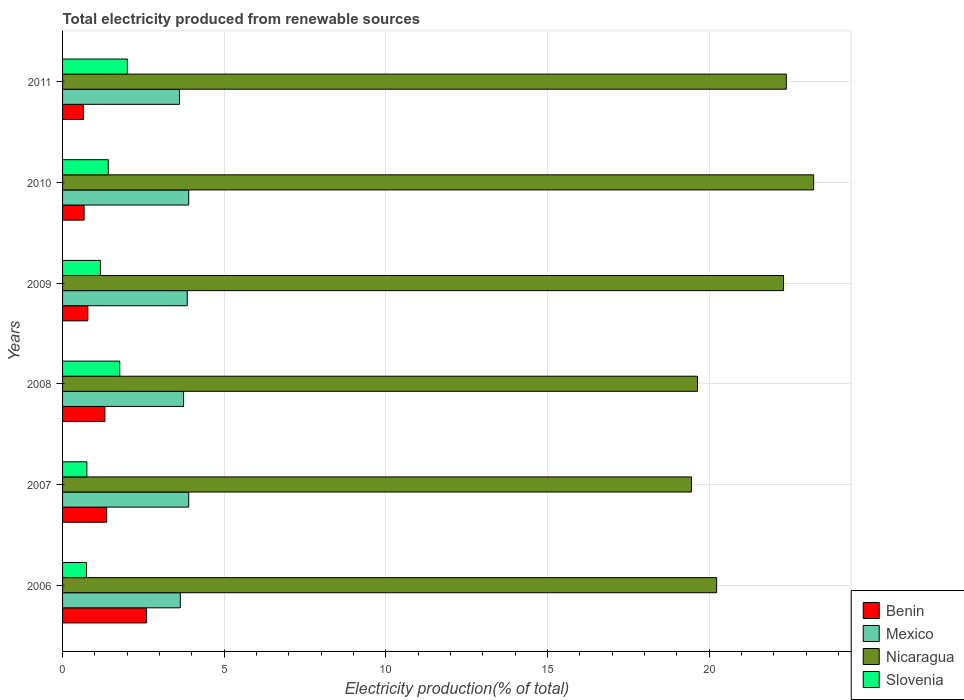Are the number of bars per tick equal to the number of legend labels?
Make the answer very short. Yes. Are the number of bars on each tick of the Y-axis equal?
Offer a terse response. Yes. How many bars are there on the 2nd tick from the top?
Provide a succinct answer. 4. How many bars are there on the 3rd tick from the bottom?
Offer a very short reply. 4. What is the label of the 4th group of bars from the top?
Provide a succinct answer. 2008. In how many cases, is the number of bars for a given year not equal to the number of legend labels?
Your answer should be compact. 0. What is the total electricity produced in Mexico in 2010?
Offer a very short reply. 3.9. Across all years, what is the maximum total electricity produced in Benin?
Your answer should be very brief. 2.6. Across all years, what is the minimum total electricity produced in Benin?
Offer a terse response. 0.65. In which year was the total electricity produced in Benin maximum?
Provide a short and direct response. 2006. What is the total total electricity produced in Mexico in the graph?
Your response must be concise. 22.66. What is the difference between the total electricity produced in Nicaragua in 2009 and that in 2010?
Offer a very short reply. -0.93. What is the difference between the total electricity produced in Nicaragua in 2009 and the total electricity produced in Mexico in 2007?
Give a very brief answer. 18.4. What is the average total electricity produced in Mexico per year?
Provide a short and direct response. 3.78. In the year 2008, what is the difference between the total electricity produced in Mexico and total electricity produced in Nicaragua?
Your answer should be compact. -15.89. What is the ratio of the total electricity produced in Nicaragua in 2006 to that in 2011?
Your answer should be very brief. 0.9. Is the total electricity produced in Slovenia in 2009 less than that in 2011?
Your response must be concise. Yes. What is the difference between the highest and the second highest total electricity produced in Slovenia?
Keep it short and to the point. 0.24. What is the difference between the highest and the lowest total electricity produced in Mexico?
Offer a terse response. 0.29. Is the sum of the total electricity produced in Slovenia in 2008 and 2010 greater than the maximum total electricity produced in Nicaragua across all years?
Your answer should be compact. No. Is it the case that in every year, the sum of the total electricity produced in Nicaragua and total electricity produced in Benin is greater than the sum of total electricity produced in Mexico and total electricity produced in Slovenia?
Provide a succinct answer. No. What does the 1st bar from the bottom in 2007 represents?
Your answer should be very brief. Benin. Is it the case that in every year, the sum of the total electricity produced in Slovenia and total electricity produced in Benin is greater than the total electricity produced in Mexico?
Your answer should be very brief. No. How many bars are there?
Make the answer very short. 24. What is the difference between two consecutive major ticks on the X-axis?
Make the answer very short. 5. Are the values on the major ticks of X-axis written in scientific E-notation?
Ensure brevity in your answer.  No. Does the graph contain any zero values?
Your answer should be compact. No. Does the graph contain grids?
Your answer should be very brief. Yes. How many legend labels are there?
Provide a short and direct response. 4. What is the title of the graph?
Your response must be concise. Total electricity produced from renewable sources. Does "Hungary" appear as one of the legend labels in the graph?
Ensure brevity in your answer.  No. What is the label or title of the Y-axis?
Provide a succinct answer. Years. What is the Electricity production(% of total) in Benin in 2006?
Provide a succinct answer. 2.6. What is the Electricity production(% of total) of Mexico in 2006?
Provide a succinct answer. 3.64. What is the Electricity production(% of total) in Nicaragua in 2006?
Provide a succinct answer. 20.23. What is the Electricity production(% of total) of Slovenia in 2006?
Your answer should be compact. 0.74. What is the Electricity production(% of total) in Benin in 2007?
Your response must be concise. 1.36. What is the Electricity production(% of total) in Mexico in 2007?
Provide a succinct answer. 3.9. What is the Electricity production(% of total) of Nicaragua in 2007?
Provide a succinct answer. 19.45. What is the Electricity production(% of total) in Slovenia in 2007?
Offer a very short reply. 0.75. What is the Electricity production(% of total) of Benin in 2008?
Give a very brief answer. 1.31. What is the Electricity production(% of total) in Mexico in 2008?
Your answer should be very brief. 3.74. What is the Electricity production(% of total) of Nicaragua in 2008?
Make the answer very short. 19.64. What is the Electricity production(% of total) in Slovenia in 2008?
Your answer should be compact. 1.77. What is the Electricity production(% of total) in Benin in 2009?
Offer a terse response. 0.78. What is the Electricity production(% of total) in Mexico in 2009?
Your answer should be compact. 3.86. What is the Electricity production(% of total) of Nicaragua in 2009?
Provide a succinct answer. 22.3. What is the Electricity production(% of total) in Slovenia in 2009?
Ensure brevity in your answer.  1.17. What is the Electricity production(% of total) of Benin in 2010?
Give a very brief answer. 0.67. What is the Electricity production(% of total) of Mexico in 2010?
Offer a very short reply. 3.9. What is the Electricity production(% of total) of Nicaragua in 2010?
Provide a short and direct response. 23.23. What is the Electricity production(% of total) in Slovenia in 2010?
Provide a short and direct response. 1.42. What is the Electricity production(% of total) of Benin in 2011?
Offer a terse response. 0.65. What is the Electricity production(% of total) of Mexico in 2011?
Give a very brief answer. 3.62. What is the Electricity production(% of total) of Nicaragua in 2011?
Make the answer very short. 22.38. What is the Electricity production(% of total) in Slovenia in 2011?
Your response must be concise. 2. Across all years, what is the maximum Electricity production(% of total) in Benin?
Your response must be concise. 2.6. Across all years, what is the maximum Electricity production(% of total) in Mexico?
Keep it short and to the point. 3.9. Across all years, what is the maximum Electricity production(% of total) in Nicaragua?
Provide a succinct answer. 23.23. Across all years, what is the maximum Electricity production(% of total) of Slovenia?
Your response must be concise. 2. Across all years, what is the minimum Electricity production(% of total) in Benin?
Give a very brief answer. 0.65. Across all years, what is the minimum Electricity production(% of total) of Mexico?
Your answer should be compact. 3.62. Across all years, what is the minimum Electricity production(% of total) of Nicaragua?
Make the answer very short. 19.45. Across all years, what is the minimum Electricity production(% of total) of Slovenia?
Offer a very short reply. 0.74. What is the total Electricity production(% of total) of Benin in the graph?
Offer a terse response. 7.36. What is the total Electricity production(% of total) in Mexico in the graph?
Provide a short and direct response. 22.66. What is the total Electricity production(% of total) in Nicaragua in the graph?
Provide a succinct answer. 127.23. What is the total Electricity production(% of total) of Slovenia in the graph?
Keep it short and to the point. 7.85. What is the difference between the Electricity production(% of total) in Benin in 2006 and that in 2007?
Give a very brief answer. 1.23. What is the difference between the Electricity production(% of total) in Mexico in 2006 and that in 2007?
Ensure brevity in your answer.  -0.26. What is the difference between the Electricity production(% of total) of Nicaragua in 2006 and that in 2007?
Provide a succinct answer. 0.78. What is the difference between the Electricity production(% of total) in Slovenia in 2006 and that in 2007?
Your response must be concise. -0.01. What is the difference between the Electricity production(% of total) in Benin in 2006 and that in 2008?
Offer a very short reply. 1.29. What is the difference between the Electricity production(% of total) in Mexico in 2006 and that in 2008?
Make the answer very short. -0.1. What is the difference between the Electricity production(% of total) of Nicaragua in 2006 and that in 2008?
Ensure brevity in your answer.  0.59. What is the difference between the Electricity production(% of total) in Slovenia in 2006 and that in 2008?
Make the answer very short. -1.03. What is the difference between the Electricity production(% of total) in Benin in 2006 and that in 2009?
Provide a short and direct response. 1.82. What is the difference between the Electricity production(% of total) in Mexico in 2006 and that in 2009?
Offer a terse response. -0.21. What is the difference between the Electricity production(% of total) in Nicaragua in 2006 and that in 2009?
Offer a terse response. -2.07. What is the difference between the Electricity production(% of total) of Slovenia in 2006 and that in 2009?
Give a very brief answer. -0.43. What is the difference between the Electricity production(% of total) in Benin in 2006 and that in 2010?
Offer a very short reply. 1.93. What is the difference between the Electricity production(% of total) in Mexico in 2006 and that in 2010?
Provide a succinct answer. -0.26. What is the difference between the Electricity production(% of total) in Nicaragua in 2006 and that in 2010?
Keep it short and to the point. -3. What is the difference between the Electricity production(% of total) of Slovenia in 2006 and that in 2010?
Give a very brief answer. -0.67. What is the difference between the Electricity production(% of total) in Benin in 2006 and that in 2011?
Provide a short and direct response. 1.95. What is the difference between the Electricity production(% of total) in Mexico in 2006 and that in 2011?
Give a very brief answer. 0.03. What is the difference between the Electricity production(% of total) in Nicaragua in 2006 and that in 2011?
Provide a short and direct response. -2.16. What is the difference between the Electricity production(% of total) of Slovenia in 2006 and that in 2011?
Offer a very short reply. -1.26. What is the difference between the Electricity production(% of total) in Benin in 2007 and that in 2008?
Provide a short and direct response. 0.05. What is the difference between the Electricity production(% of total) of Mexico in 2007 and that in 2008?
Keep it short and to the point. 0.16. What is the difference between the Electricity production(% of total) of Nicaragua in 2007 and that in 2008?
Your answer should be compact. -0.19. What is the difference between the Electricity production(% of total) of Slovenia in 2007 and that in 2008?
Ensure brevity in your answer.  -1.02. What is the difference between the Electricity production(% of total) in Benin in 2007 and that in 2009?
Your answer should be very brief. 0.58. What is the difference between the Electricity production(% of total) of Mexico in 2007 and that in 2009?
Keep it short and to the point. 0.05. What is the difference between the Electricity production(% of total) in Nicaragua in 2007 and that in 2009?
Your answer should be very brief. -2.85. What is the difference between the Electricity production(% of total) of Slovenia in 2007 and that in 2009?
Your answer should be compact. -0.42. What is the difference between the Electricity production(% of total) of Benin in 2007 and that in 2010?
Keep it short and to the point. 0.7. What is the difference between the Electricity production(% of total) of Mexico in 2007 and that in 2010?
Keep it short and to the point. -0. What is the difference between the Electricity production(% of total) of Nicaragua in 2007 and that in 2010?
Provide a short and direct response. -3.78. What is the difference between the Electricity production(% of total) in Slovenia in 2007 and that in 2010?
Ensure brevity in your answer.  -0.66. What is the difference between the Electricity production(% of total) in Benin in 2007 and that in 2011?
Your answer should be compact. 0.72. What is the difference between the Electricity production(% of total) of Mexico in 2007 and that in 2011?
Offer a very short reply. 0.29. What is the difference between the Electricity production(% of total) of Nicaragua in 2007 and that in 2011?
Offer a very short reply. -2.93. What is the difference between the Electricity production(% of total) of Slovenia in 2007 and that in 2011?
Offer a very short reply. -1.25. What is the difference between the Electricity production(% of total) of Benin in 2008 and that in 2009?
Offer a terse response. 0.53. What is the difference between the Electricity production(% of total) of Mexico in 2008 and that in 2009?
Your answer should be compact. -0.11. What is the difference between the Electricity production(% of total) of Nicaragua in 2008 and that in 2009?
Your answer should be compact. -2.66. What is the difference between the Electricity production(% of total) in Slovenia in 2008 and that in 2009?
Provide a succinct answer. 0.6. What is the difference between the Electricity production(% of total) of Benin in 2008 and that in 2010?
Provide a succinct answer. 0.64. What is the difference between the Electricity production(% of total) in Mexico in 2008 and that in 2010?
Your response must be concise. -0.16. What is the difference between the Electricity production(% of total) of Nicaragua in 2008 and that in 2010?
Make the answer very short. -3.59. What is the difference between the Electricity production(% of total) in Slovenia in 2008 and that in 2010?
Your answer should be compact. 0.35. What is the difference between the Electricity production(% of total) in Benin in 2008 and that in 2011?
Your response must be concise. 0.66. What is the difference between the Electricity production(% of total) of Mexico in 2008 and that in 2011?
Offer a terse response. 0.13. What is the difference between the Electricity production(% of total) of Nicaragua in 2008 and that in 2011?
Offer a terse response. -2.75. What is the difference between the Electricity production(% of total) of Slovenia in 2008 and that in 2011?
Ensure brevity in your answer.  -0.24. What is the difference between the Electricity production(% of total) in Benin in 2009 and that in 2010?
Provide a short and direct response. 0.11. What is the difference between the Electricity production(% of total) of Mexico in 2009 and that in 2010?
Your answer should be compact. -0.05. What is the difference between the Electricity production(% of total) in Nicaragua in 2009 and that in 2010?
Your answer should be very brief. -0.93. What is the difference between the Electricity production(% of total) of Slovenia in 2009 and that in 2010?
Your response must be concise. -0.24. What is the difference between the Electricity production(% of total) in Benin in 2009 and that in 2011?
Your answer should be compact. 0.14. What is the difference between the Electricity production(% of total) of Mexico in 2009 and that in 2011?
Offer a terse response. 0.24. What is the difference between the Electricity production(% of total) of Nicaragua in 2009 and that in 2011?
Provide a short and direct response. -0.09. What is the difference between the Electricity production(% of total) in Slovenia in 2009 and that in 2011?
Ensure brevity in your answer.  -0.83. What is the difference between the Electricity production(% of total) in Benin in 2010 and that in 2011?
Ensure brevity in your answer.  0.02. What is the difference between the Electricity production(% of total) of Mexico in 2010 and that in 2011?
Offer a terse response. 0.29. What is the difference between the Electricity production(% of total) of Nicaragua in 2010 and that in 2011?
Keep it short and to the point. 0.85. What is the difference between the Electricity production(% of total) in Slovenia in 2010 and that in 2011?
Provide a succinct answer. -0.59. What is the difference between the Electricity production(% of total) of Benin in 2006 and the Electricity production(% of total) of Mexico in 2007?
Keep it short and to the point. -1.3. What is the difference between the Electricity production(% of total) in Benin in 2006 and the Electricity production(% of total) in Nicaragua in 2007?
Offer a very short reply. -16.85. What is the difference between the Electricity production(% of total) in Benin in 2006 and the Electricity production(% of total) in Slovenia in 2007?
Provide a succinct answer. 1.85. What is the difference between the Electricity production(% of total) of Mexico in 2006 and the Electricity production(% of total) of Nicaragua in 2007?
Provide a succinct answer. -15.81. What is the difference between the Electricity production(% of total) of Mexico in 2006 and the Electricity production(% of total) of Slovenia in 2007?
Your answer should be compact. 2.89. What is the difference between the Electricity production(% of total) of Nicaragua in 2006 and the Electricity production(% of total) of Slovenia in 2007?
Your response must be concise. 19.48. What is the difference between the Electricity production(% of total) of Benin in 2006 and the Electricity production(% of total) of Mexico in 2008?
Your response must be concise. -1.15. What is the difference between the Electricity production(% of total) of Benin in 2006 and the Electricity production(% of total) of Nicaragua in 2008?
Provide a short and direct response. -17.04. What is the difference between the Electricity production(% of total) in Benin in 2006 and the Electricity production(% of total) in Slovenia in 2008?
Your answer should be very brief. 0.83. What is the difference between the Electricity production(% of total) in Mexico in 2006 and the Electricity production(% of total) in Nicaragua in 2008?
Provide a short and direct response. -16. What is the difference between the Electricity production(% of total) in Mexico in 2006 and the Electricity production(% of total) in Slovenia in 2008?
Ensure brevity in your answer.  1.87. What is the difference between the Electricity production(% of total) in Nicaragua in 2006 and the Electricity production(% of total) in Slovenia in 2008?
Your answer should be compact. 18.46. What is the difference between the Electricity production(% of total) of Benin in 2006 and the Electricity production(% of total) of Mexico in 2009?
Offer a very short reply. -1.26. What is the difference between the Electricity production(% of total) in Benin in 2006 and the Electricity production(% of total) in Nicaragua in 2009?
Make the answer very short. -19.7. What is the difference between the Electricity production(% of total) of Benin in 2006 and the Electricity production(% of total) of Slovenia in 2009?
Give a very brief answer. 1.43. What is the difference between the Electricity production(% of total) of Mexico in 2006 and the Electricity production(% of total) of Nicaragua in 2009?
Provide a short and direct response. -18.66. What is the difference between the Electricity production(% of total) in Mexico in 2006 and the Electricity production(% of total) in Slovenia in 2009?
Your answer should be very brief. 2.47. What is the difference between the Electricity production(% of total) in Nicaragua in 2006 and the Electricity production(% of total) in Slovenia in 2009?
Make the answer very short. 19.06. What is the difference between the Electricity production(% of total) of Benin in 2006 and the Electricity production(% of total) of Mexico in 2010?
Offer a terse response. -1.3. What is the difference between the Electricity production(% of total) of Benin in 2006 and the Electricity production(% of total) of Nicaragua in 2010?
Offer a very short reply. -20.63. What is the difference between the Electricity production(% of total) in Benin in 2006 and the Electricity production(% of total) in Slovenia in 2010?
Offer a terse response. 1.18. What is the difference between the Electricity production(% of total) in Mexico in 2006 and the Electricity production(% of total) in Nicaragua in 2010?
Your response must be concise. -19.59. What is the difference between the Electricity production(% of total) in Mexico in 2006 and the Electricity production(% of total) in Slovenia in 2010?
Give a very brief answer. 2.23. What is the difference between the Electricity production(% of total) of Nicaragua in 2006 and the Electricity production(% of total) of Slovenia in 2010?
Make the answer very short. 18.81. What is the difference between the Electricity production(% of total) in Benin in 2006 and the Electricity production(% of total) in Mexico in 2011?
Your answer should be very brief. -1.02. What is the difference between the Electricity production(% of total) in Benin in 2006 and the Electricity production(% of total) in Nicaragua in 2011?
Make the answer very short. -19.79. What is the difference between the Electricity production(% of total) of Benin in 2006 and the Electricity production(% of total) of Slovenia in 2011?
Your response must be concise. 0.59. What is the difference between the Electricity production(% of total) in Mexico in 2006 and the Electricity production(% of total) in Nicaragua in 2011?
Keep it short and to the point. -18.74. What is the difference between the Electricity production(% of total) in Mexico in 2006 and the Electricity production(% of total) in Slovenia in 2011?
Keep it short and to the point. 1.64. What is the difference between the Electricity production(% of total) in Nicaragua in 2006 and the Electricity production(% of total) in Slovenia in 2011?
Your answer should be compact. 18.23. What is the difference between the Electricity production(% of total) of Benin in 2007 and the Electricity production(% of total) of Mexico in 2008?
Your response must be concise. -2.38. What is the difference between the Electricity production(% of total) of Benin in 2007 and the Electricity production(% of total) of Nicaragua in 2008?
Offer a very short reply. -18.27. What is the difference between the Electricity production(% of total) in Benin in 2007 and the Electricity production(% of total) in Slovenia in 2008?
Your answer should be very brief. -0.4. What is the difference between the Electricity production(% of total) of Mexico in 2007 and the Electricity production(% of total) of Nicaragua in 2008?
Give a very brief answer. -15.74. What is the difference between the Electricity production(% of total) of Mexico in 2007 and the Electricity production(% of total) of Slovenia in 2008?
Ensure brevity in your answer.  2.13. What is the difference between the Electricity production(% of total) in Nicaragua in 2007 and the Electricity production(% of total) in Slovenia in 2008?
Give a very brief answer. 17.68. What is the difference between the Electricity production(% of total) of Benin in 2007 and the Electricity production(% of total) of Mexico in 2009?
Keep it short and to the point. -2.49. What is the difference between the Electricity production(% of total) in Benin in 2007 and the Electricity production(% of total) in Nicaragua in 2009?
Your response must be concise. -20.94. What is the difference between the Electricity production(% of total) of Benin in 2007 and the Electricity production(% of total) of Slovenia in 2009?
Your answer should be very brief. 0.19. What is the difference between the Electricity production(% of total) in Mexico in 2007 and the Electricity production(% of total) in Nicaragua in 2009?
Ensure brevity in your answer.  -18.4. What is the difference between the Electricity production(% of total) of Mexico in 2007 and the Electricity production(% of total) of Slovenia in 2009?
Provide a succinct answer. 2.73. What is the difference between the Electricity production(% of total) in Nicaragua in 2007 and the Electricity production(% of total) in Slovenia in 2009?
Ensure brevity in your answer.  18.28. What is the difference between the Electricity production(% of total) of Benin in 2007 and the Electricity production(% of total) of Mexico in 2010?
Provide a succinct answer. -2.54. What is the difference between the Electricity production(% of total) in Benin in 2007 and the Electricity production(% of total) in Nicaragua in 2010?
Your answer should be very brief. -21.87. What is the difference between the Electricity production(% of total) in Benin in 2007 and the Electricity production(% of total) in Slovenia in 2010?
Offer a terse response. -0.05. What is the difference between the Electricity production(% of total) of Mexico in 2007 and the Electricity production(% of total) of Nicaragua in 2010?
Your answer should be very brief. -19.33. What is the difference between the Electricity production(% of total) of Mexico in 2007 and the Electricity production(% of total) of Slovenia in 2010?
Ensure brevity in your answer.  2.49. What is the difference between the Electricity production(% of total) of Nicaragua in 2007 and the Electricity production(% of total) of Slovenia in 2010?
Your answer should be very brief. 18.04. What is the difference between the Electricity production(% of total) in Benin in 2007 and the Electricity production(% of total) in Mexico in 2011?
Offer a terse response. -2.25. What is the difference between the Electricity production(% of total) in Benin in 2007 and the Electricity production(% of total) in Nicaragua in 2011?
Offer a terse response. -21.02. What is the difference between the Electricity production(% of total) of Benin in 2007 and the Electricity production(% of total) of Slovenia in 2011?
Your response must be concise. -0.64. What is the difference between the Electricity production(% of total) in Mexico in 2007 and the Electricity production(% of total) in Nicaragua in 2011?
Keep it short and to the point. -18.48. What is the difference between the Electricity production(% of total) of Mexico in 2007 and the Electricity production(% of total) of Slovenia in 2011?
Make the answer very short. 1.9. What is the difference between the Electricity production(% of total) of Nicaragua in 2007 and the Electricity production(% of total) of Slovenia in 2011?
Your response must be concise. 17.45. What is the difference between the Electricity production(% of total) in Benin in 2008 and the Electricity production(% of total) in Mexico in 2009?
Your response must be concise. -2.55. What is the difference between the Electricity production(% of total) of Benin in 2008 and the Electricity production(% of total) of Nicaragua in 2009?
Offer a very short reply. -20.99. What is the difference between the Electricity production(% of total) in Benin in 2008 and the Electricity production(% of total) in Slovenia in 2009?
Provide a short and direct response. 0.14. What is the difference between the Electricity production(% of total) of Mexico in 2008 and the Electricity production(% of total) of Nicaragua in 2009?
Give a very brief answer. -18.56. What is the difference between the Electricity production(% of total) in Mexico in 2008 and the Electricity production(% of total) in Slovenia in 2009?
Offer a very short reply. 2.57. What is the difference between the Electricity production(% of total) of Nicaragua in 2008 and the Electricity production(% of total) of Slovenia in 2009?
Make the answer very short. 18.47. What is the difference between the Electricity production(% of total) in Benin in 2008 and the Electricity production(% of total) in Mexico in 2010?
Your answer should be compact. -2.59. What is the difference between the Electricity production(% of total) of Benin in 2008 and the Electricity production(% of total) of Nicaragua in 2010?
Keep it short and to the point. -21.92. What is the difference between the Electricity production(% of total) in Benin in 2008 and the Electricity production(% of total) in Slovenia in 2010?
Your answer should be compact. -0.11. What is the difference between the Electricity production(% of total) of Mexico in 2008 and the Electricity production(% of total) of Nicaragua in 2010?
Make the answer very short. -19.49. What is the difference between the Electricity production(% of total) in Mexico in 2008 and the Electricity production(% of total) in Slovenia in 2010?
Offer a very short reply. 2.33. What is the difference between the Electricity production(% of total) of Nicaragua in 2008 and the Electricity production(% of total) of Slovenia in 2010?
Ensure brevity in your answer.  18.22. What is the difference between the Electricity production(% of total) in Benin in 2008 and the Electricity production(% of total) in Mexico in 2011?
Provide a short and direct response. -2.31. What is the difference between the Electricity production(% of total) of Benin in 2008 and the Electricity production(% of total) of Nicaragua in 2011?
Give a very brief answer. -21.07. What is the difference between the Electricity production(% of total) in Benin in 2008 and the Electricity production(% of total) in Slovenia in 2011?
Offer a very short reply. -0.69. What is the difference between the Electricity production(% of total) of Mexico in 2008 and the Electricity production(% of total) of Nicaragua in 2011?
Provide a short and direct response. -18.64. What is the difference between the Electricity production(% of total) of Mexico in 2008 and the Electricity production(% of total) of Slovenia in 2011?
Offer a very short reply. 1.74. What is the difference between the Electricity production(% of total) in Nicaragua in 2008 and the Electricity production(% of total) in Slovenia in 2011?
Provide a short and direct response. 17.63. What is the difference between the Electricity production(% of total) in Benin in 2009 and the Electricity production(% of total) in Mexico in 2010?
Keep it short and to the point. -3.12. What is the difference between the Electricity production(% of total) of Benin in 2009 and the Electricity production(% of total) of Nicaragua in 2010?
Offer a terse response. -22.45. What is the difference between the Electricity production(% of total) of Benin in 2009 and the Electricity production(% of total) of Slovenia in 2010?
Provide a short and direct response. -0.63. What is the difference between the Electricity production(% of total) of Mexico in 2009 and the Electricity production(% of total) of Nicaragua in 2010?
Offer a terse response. -19.37. What is the difference between the Electricity production(% of total) of Mexico in 2009 and the Electricity production(% of total) of Slovenia in 2010?
Your response must be concise. 2.44. What is the difference between the Electricity production(% of total) in Nicaragua in 2009 and the Electricity production(% of total) in Slovenia in 2010?
Your response must be concise. 20.88. What is the difference between the Electricity production(% of total) of Benin in 2009 and the Electricity production(% of total) of Mexico in 2011?
Keep it short and to the point. -2.83. What is the difference between the Electricity production(% of total) in Benin in 2009 and the Electricity production(% of total) in Nicaragua in 2011?
Your response must be concise. -21.6. What is the difference between the Electricity production(% of total) of Benin in 2009 and the Electricity production(% of total) of Slovenia in 2011?
Your response must be concise. -1.22. What is the difference between the Electricity production(% of total) in Mexico in 2009 and the Electricity production(% of total) in Nicaragua in 2011?
Make the answer very short. -18.53. What is the difference between the Electricity production(% of total) of Mexico in 2009 and the Electricity production(% of total) of Slovenia in 2011?
Give a very brief answer. 1.85. What is the difference between the Electricity production(% of total) of Nicaragua in 2009 and the Electricity production(% of total) of Slovenia in 2011?
Your answer should be compact. 20.29. What is the difference between the Electricity production(% of total) of Benin in 2010 and the Electricity production(% of total) of Mexico in 2011?
Give a very brief answer. -2.95. What is the difference between the Electricity production(% of total) of Benin in 2010 and the Electricity production(% of total) of Nicaragua in 2011?
Keep it short and to the point. -21.72. What is the difference between the Electricity production(% of total) in Benin in 2010 and the Electricity production(% of total) in Slovenia in 2011?
Ensure brevity in your answer.  -1.34. What is the difference between the Electricity production(% of total) in Mexico in 2010 and the Electricity production(% of total) in Nicaragua in 2011?
Provide a succinct answer. -18.48. What is the difference between the Electricity production(% of total) of Mexico in 2010 and the Electricity production(% of total) of Slovenia in 2011?
Your response must be concise. 1.9. What is the difference between the Electricity production(% of total) of Nicaragua in 2010 and the Electricity production(% of total) of Slovenia in 2011?
Make the answer very short. 21.23. What is the average Electricity production(% of total) of Benin per year?
Your answer should be very brief. 1.23. What is the average Electricity production(% of total) of Mexico per year?
Offer a terse response. 3.78. What is the average Electricity production(% of total) of Nicaragua per year?
Give a very brief answer. 21.21. What is the average Electricity production(% of total) in Slovenia per year?
Your answer should be compact. 1.31. In the year 2006, what is the difference between the Electricity production(% of total) of Benin and Electricity production(% of total) of Mexico?
Make the answer very short. -1.04. In the year 2006, what is the difference between the Electricity production(% of total) of Benin and Electricity production(% of total) of Nicaragua?
Provide a short and direct response. -17.63. In the year 2006, what is the difference between the Electricity production(% of total) in Benin and Electricity production(% of total) in Slovenia?
Your response must be concise. 1.86. In the year 2006, what is the difference between the Electricity production(% of total) in Mexico and Electricity production(% of total) in Nicaragua?
Ensure brevity in your answer.  -16.59. In the year 2006, what is the difference between the Electricity production(% of total) in Mexico and Electricity production(% of total) in Slovenia?
Offer a very short reply. 2.9. In the year 2006, what is the difference between the Electricity production(% of total) in Nicaragua and Electricity production(% of total) in Slovenia?
Provide a short and direct response. 19.49. In the year 2007, what is the difference between the Electricity production(% of total) of Benin and Electricity production(% of total) of Mexico?
Give a very brief answer. -2.54. In the year 2007, what is the difference between the Electricity production(% of total) of Benin and Electricity production(% of total) of Nicaragua?
Ensure brevity in your answer.  -18.09. In the year 2007, what is the difference between the Electricity production(% of total) in Benin and Electricity production(% of total) in Slovenia?
Your answer should be very brief. 0.61. In the year 2007, what is the difference between the Electricity production(% of total) of Mexico and Electricity production(% of total) of Nicaragua?
Offer a terse response. -15.55. In the year 2007, what is the difference between the Electricity production(% of total) in Mexico and Electricity production(% of total) in Slovenia?
Keep it short and to the point. 3.15. In the year 2007, what is the difference between the Electricity production(% of total) in Nicaragua and Electricity production(% of total) in Slovenia?
Give a very brief answer. 18.7. In the year 2008, what is the difference between the Electricity production(% of total) of Benin and Electricity production(% of total) of Mexico?
Make the answer very short. -2.43. In the year 2008, what is the difference between the Electricity production(% of total) of Benin and Electricity production(% of total) of Nicaragua?
Offer a terse response. -18.33. In the year 2008, what is the difference between the Electricity production(% of total) in Benin and Electricity production(% of total) in Slovenia?
Ensure brevity in your answer.  -0.46. In the year 2008, what is the difference between the Electricity production(% of total) of Mexico and Electricity production(% of total) of Nicaragua?
Your answer should be very brief. -15.89. In the year 2008, what is the difference between the Electricity production(% of total) of Mexico and Electricity production(% of total) of Slovenia?
Ensure brevity in your answer.  1.97. In the year 2008, what is the difference between the Electricity production(% of total) of Nicaragua and Electricity production(% of total) of Slovenia?
Provide a short and direct response. 17.87. In the year 2009, what is the difference between the Electricity production(% of total) in Benin and Electricity production(% of total) in Mexico?
Offer a terse response. -3.07. In the year 2009, what is the difference between the Electricity production(% of total) in Benin and Electricity production(% of total) in Nicaragua?
Make the answer very short. -21.52. In the year 2009, what is the difference between the Electricity production(% of total) of Benin and Electricity production(% of total) of Slovenia?
Give a very brief answer. -0.39. In the year 2009, what is the difference between the Electricity production(% of total) of Mexico and Electricity production(% of total) of Nicaragua?
Provide a succinct answer. -18.44. In the year 2009, what is the difference between the Electricity production(% of total) of Mexico and Electricity production(% of total) of Slovenia?
Your answer should be very brief. 2.69. In the year 2009, what is the difference between the Electricity production(% of total) of Nicaragua and Electricity production(% of total) of Slovenia?
Give a very brief answer. 21.13. In the year 2010, what is the difference between the Electricity production(% of total) of Benin and Electricity production(% of total) of Mexico?
Offer a terse response. -3.24. In the year 2010, what is the difference between the Electricity production(% of total) in Benin and Electricity production(% of total) in Nicaragua?
Your answer should be compact. -22.56. In the year 2010, what is the difference between the Electricity production(% of total) of Benin and Electricity production(% of total) of Slovenia?
Provide a succinct answer. -0.75. In the year 2010, what is the difference between the Electricity production(% of total) of Mexico and Electricity production(% of total) of Nicaragua?
Ensure brevity in your answer.  -19.33. In the year 2010, what is the difference between the Electricity production(% of total) in Mexico and Electricity production(% of total) in Slovenia?
Your answer should be compact. 2.49. In the year 2010, what is the difference between the Electricity production(% of total) of Nicaragua and Electricity production(% of total) of Slovenia?
Offer a very short reply. 21.81. In the year 2011, what is the difference between the Electricity production(% of total) in Benin and Electricity production(% of total) in Mexico?
Offer a very short reply. -2.97. In the year 2011, what is the difference between the Electricity production(% of total) of Benin and Electricity production(% of total) of Nicaragua?
Give a very brief answer. -21.74. In the year 2011, what is the difference between the Electricity production(% of total) in Benin and Electricity production(% of total) in Slovenia?
Your response must be concise. -1.36. In the year 2011, what is the difference between the Electricity production(% of total) of Mexico and Electricity production(% of total) of Nicaragua?
Offer a terse response. -18.77. In the year 2011, what is the difference between the Electricity production(% of total) of Mexico and Electricity production(% of total) of Slovenia?
Keep it short and to the point. 1.61. In the year 2011, what is the difference between the Electricity production(% of total) of Nicaragua and Electricity production(% of total) of Slovenia?
Provide a succinct answer. 20.38. What is the ratio of the Electricity production(% of total) in Benin in 2006 to that in 2007?
Offer a very short reply. 1.9. What is the ratio of the Electricity production(% of total) of Mexico in 2006 to that in 2007?
Your response must be concise. 0.93. What is the ratio of the Electricity production(% of total) in Slovenia in 2006 to that in 2007?
Give a very brief answer. 0.99. What is the ratio of the Electricity production(% of total) of Benin in 2006 to that in 2008?
Provide a succinct answer. 1.98. What is the ratio of the Electricity production(% of total) in Mexico in 2006 to that in 2008?
Your answer should be very brief. 0.97. What is the ratio of the Electricity production(% of total) in Nicaragua in 2006 to that in 2008?
Make the answer very short. 1.03. What is the ratio of the Electricity production(% of total) of Slovenia in 2006 to that in 2008?
Offer a terse response. 0.42. What is the ratio of the Electricity production(% of total) in Benin in 2006 to that in 2009?
Ensure brevity in your answer.  3.32. What is the ratio of the Electricity production(% of total) in Mexico in 2006 to that in 2009?
Give a very brief answer. 0.94. What is the ratio of the Electricity production(% of total) of Nicaragua in 2006 to that in 2009?
Make the answer very short. 0.91. What is the ratio of the Electricity production(% of total) in Slovenia in 2006 to that in 2009?
Give a very brief answer. 0.63. What is the ratio of the Electricity production(% of total) in Benin in 2006 to that in 2010?
Give a very brief answer. 3.9. What is the ratio of the Electricity production(% of total) of Mexico in 2006 to that in 2010?
Keep it short and to the point. 0.93. What is the ratio of the Electricity production(% of total) of Nicaragua in 2006 to that in 2010?
Your answer should be very brief. 0.87. What is the ratio of the Electricity production(% of total) of Slovenia in 2006 to that in 2010?
Keep it short and to the point. 0.52. What is the ratio of the Electricity production(% of total) of Benin in 2006 to that in 2011?
Make the answer very short. 4.03. What is the ratio of the Electricity production(% of total) in Mexico in 2006 to that in 2011?
Offer a very short reply. 1.01. What is the ratio of the Electricity production(% of total) in Nicaragua in 2006 to that in 2011?
Provide a succinct answer. 0.9. What is the ratio of the Electricity production(% of total) of Slovenia in 2006 to that in 2011?
Make the answer very short. 0.37. What is the ratio of the Electricity production(% of total) in Benin in 2007 to that in 2008?
Your answer should be compact. 1.04. What is the ratio of the Electricity production(% of total) of Mexico in 2007 to that in 2008?
Offer a very short reply. 1.04. What is the ratio of the Electricity production(% of total) of Slovenia in 2007 to that in 2008?
Provide a succinct answer. 0.42. What is the ratio of the Electricity production(% of total) in Benin in 2007 to that in 2009?
Your answer should be very brief. 1.75. What is the ratio of the Electricity production(% of total) of Mexico in 2007 to that in 2009?
Your response must be concise. 1.01. What is the ratio of the Electricity production(% of total) of Nicaragua in 2007 to that in 2009?
Your answer should be very brief. 0.87. What is the ratio of the Electricity production(% of total) of Slovenia in 2007 to that in 2009?
Give a very brief answer. 0.64. What is the ratio of the Electricity production(% of total) of Benin in 2007 to that in 2010?
Offer a terse response. 2.05. What is the ratio of the Electricity production(% of total) in Mexico in 2007 to that in 2010?
Make the answer very short. 1. What is the ratio of the Electricity production(% of total) of Nicaragua in 2007 to that in 2010?
Offer a terse response. 0.84. What is the ratio of the Electricity production(% of total) of Slovenia in 2007 to that in 2010?
Keep it short and to the point. 0.53. What is the ratio of the Electricity production(% of total) in Benin in 2007 to that in 2011?
Make the answer very short. 2.11. What is the ratio of the Electricity production(% of total) of Mexico in 2007 to that in 2011?
Provide a short and direct response. 1.08. What is the ratio of the Electricity production(% of total) of Nicaragua in 2007 to that in 2011?
Give a very brief answer. 0.87. What is the ratio of the Electricity production(% of total) of Slovenia in 2007 to that in 2011?
Your answer should be very brief. 0.37. What is the ratio of the Electricity production(% of total) in Benin in 2008 to that in 2009?
Your response must be concise. 1.68. What is the ratio of the Electricity production(% of total) of Mexico in 2008 to that in 2009?
Your response must be concise. 0.97. What is the ratio of the Electricity production(% of total) in Nicaragua in 2008 to that in 2009?
Your response must be concise. 0.88. What is the ratio of the Electricity production(% of total) of Slovenia in 2008 to that in 2009?
Provide a short and direct response. 1.51. What is the ratio of the Electricity production(% of total) in Benin in 2008 to that in 2010?
Your answer should be very brief. 1.97. What is the ratio of the Electricity production(% of total) of Mexico in 2008 to that in 2010?
Keep it short and to the point. 0.96. What is the ratio of the Electricity production(% of total) in Nicaragua in 2008 to that in 2010?
Keep it short and to the point. 0.85. What is the ratio of the Electricity production(% of total) of Slovenia in 2008 to that in 2010?
Offer a terse response. 1.25. What is the ratio of the Electricity production(% of total) in Benin in 2008 to that in 2011?
Your answer should be compact. 2.03. What is the ratio of the Electricity production(% of total) of Mexico in 2008 to that in 2011?
Keep it short and to the point. 1.04. What is the ratio of the Electricity production(% of total) of Nicaragua in 2008 to that in 2011?
Provide a short and direct response. 0.88. What is the ratio of the Electricity production(% of total) in Slovenia in 2008 to that in 2011?
Your response must be concise. 0.88. What is the ratio of the Electricity production(% of total) of Benin in 2009 to that in 2010?
Offer a terse response. 1.17. What is the ratio of the Electricity production(% of total) of Mexico in 2009 to that in 2010?
Offer a terse response. 0.99. What is the ratio of the Electricity production(% of total) of Nicaragua in 2009 to that in 2010?
Keep it short and to the point. 0.96. What is the ratio of the Electricity production(% of total) of Slovenia in 2009 to that in 2010?
Provide a short and direct response. 0.83. What is the ratio of the Electricity production(% of total) in Benin in 2009 to that in 2011?
Ensure brevity in your answer.  1.21. What is the ratio of the Electricity production(% of total) of Mexico in 2009 to that in 2011?
Your answer should be very brief. 1.07. What is the ratio of the Electricity production(% of total) in Slovenia in 2009 to that in 2011?
Offer a very short reply. 0.58. What is the ratio of the Electricity production(% of total) in Mexico in 2010 to that in 2011?
Offer a very short reply. 1.08. What is the ratio of the Electricity production(% of total) in Nicaragua in 2010 to that in 2011?
Provide a short and direct response. 1.04. What is the ratio of the Electricity production(% of total) of Slovenia in 2010 to that in 2011?
Offer a very short reply. 0.71. What is the difference between the highest and the second highest Electricity production(% of total) of Benin?
Give a very brief answer. 1.23. What is the difference between the highest and the second highest Electricity production(% of total) in Mexico?
Give a very brief answer. 0. What is the difference between the highest and the second highest Electricity production(% of total) in Nicaragua?
Keep it short and to the point. 0.85. What is the difference between the highest and the second highest Electricity production(% of total) of Slovenia?
Ensure brevity in your answer.  0.24. What is the difference between the highest and the lowest Electricity production(% of total) of Benin?
Give a very brief answer. 1.95. What is the difference between the highest and the lowest Electricity production(% of total) of Mexico?
Provide a succinct answer. 0.29. What is the difference between the highest and the lowest Electricity production(% of total) in Nicaragua?
Your response must be concise. 3.78. What is the difference between the highest and the lowest Electricity production(% of total) in Slovenia?
Offer a terse response. 1.26. 